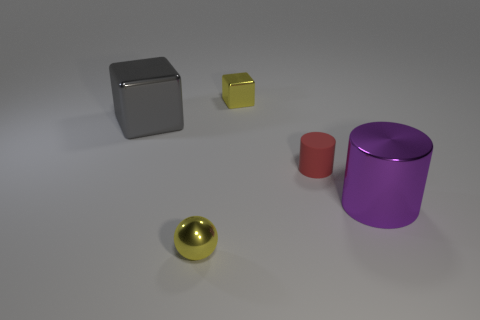There is a shiny object that is both on the right side of the yellow ball and in front of the tiny block; what is its size?
Make the answer very short. Large. There is a cylinder that is the same material as the tiny yellow ball; what color is it?
Provide a succinct answer. Purple. What number of big cyan blocks are the same material as the large cylinder?
Your answer should be compact. 0. Are there the same number of tiny cylinders that are to the right of the purple shiny cylinder and gray blocks in front of the small red rubber thing?
Offer a very short reply. Yes. There is a tiny red thing; is its shape the same as the yellow object that is behind the tiny sphere?
Make the answer very short. No. What material is the tiny block that is the same color as the shiny ball?
Give a very brief answer. Metal. Is there anything else that is the same shape as the tiny red thing?
Your response must be concise. Yes. Is the material of the purple cylinder the same as the yellow object in front of the shiny cylinder?
Your answer should be very brief. Yes. What is the color of the small cylinder to the right of the tiny metallic thing in front of the yellow object that is behind the purple metal cylinder?
Offer a very short reply. Red. Are there any other things that have the same size as the ball?
Provide a short and direct response. Yes. 